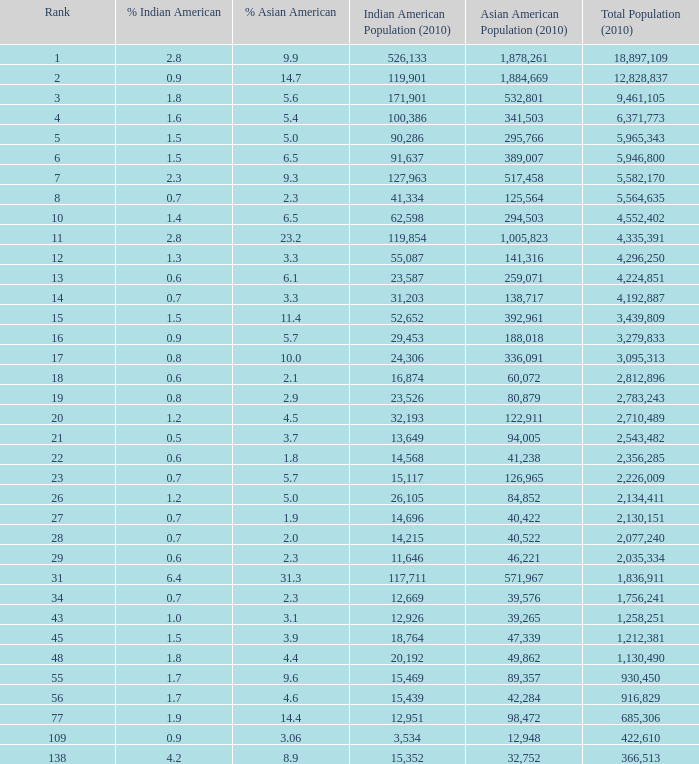What's the total population when the Asian American population is less than 60,072, the Indian American population is more than 14,696 and is 4.2% Indian American? 366513.0. 